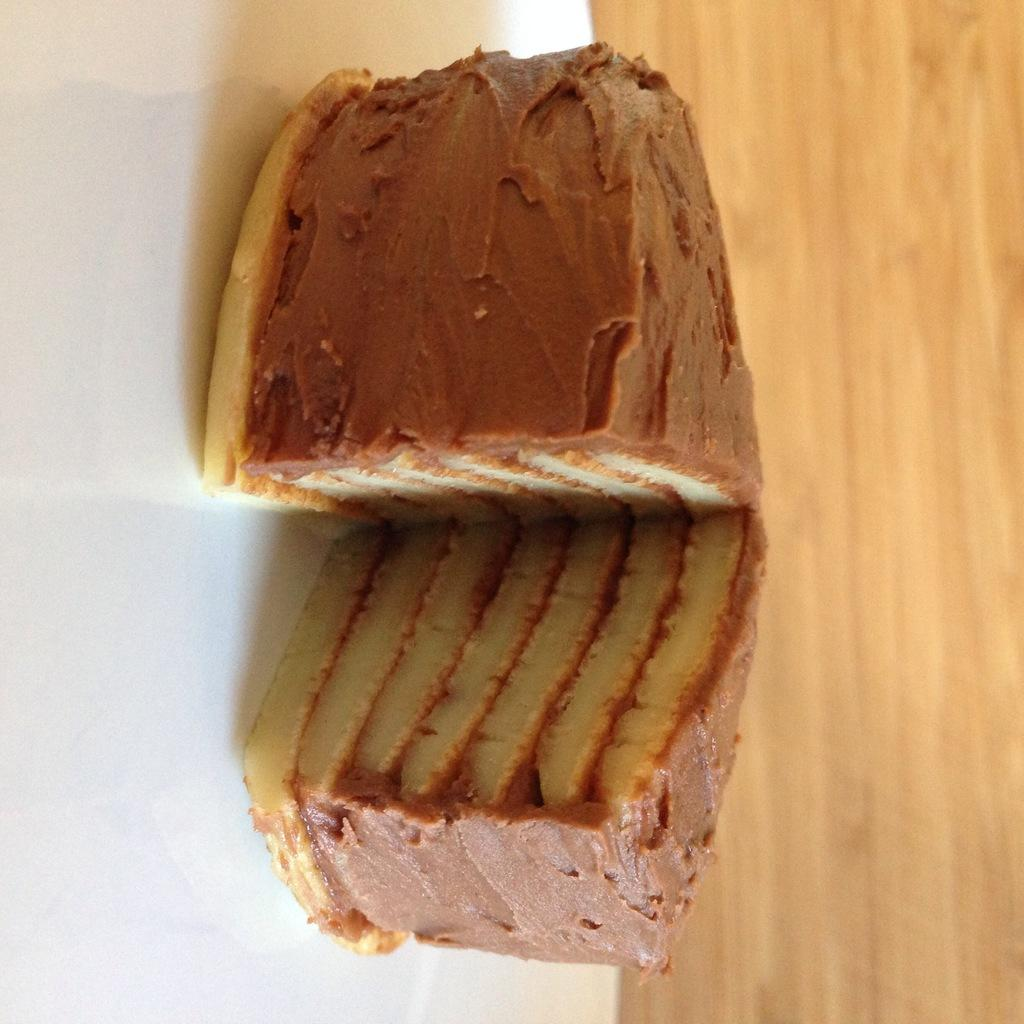What is on the plate that is visible in the image? There is food in a plate in the image. What type of surface is at the bottom of the image? There is a wooden surface at the bottom of the image. What type of wax can be seen melting on the wooden surface in the image? There is no wax present in the image; it only features food on a plate and a wooden surface. 